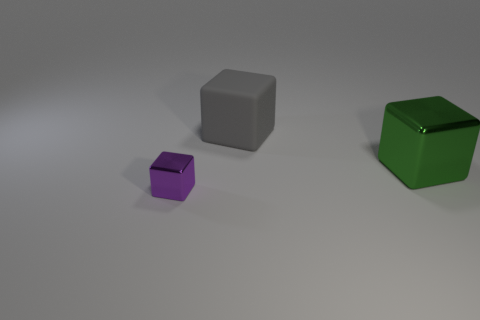Does the large green object have the same shape as the purple metal object? Yes, the large green object and the purple object both have a cubic shape, characterized by their six square faces, twelve straight edges, and eight vertices. The predominant difference is their size and color. 